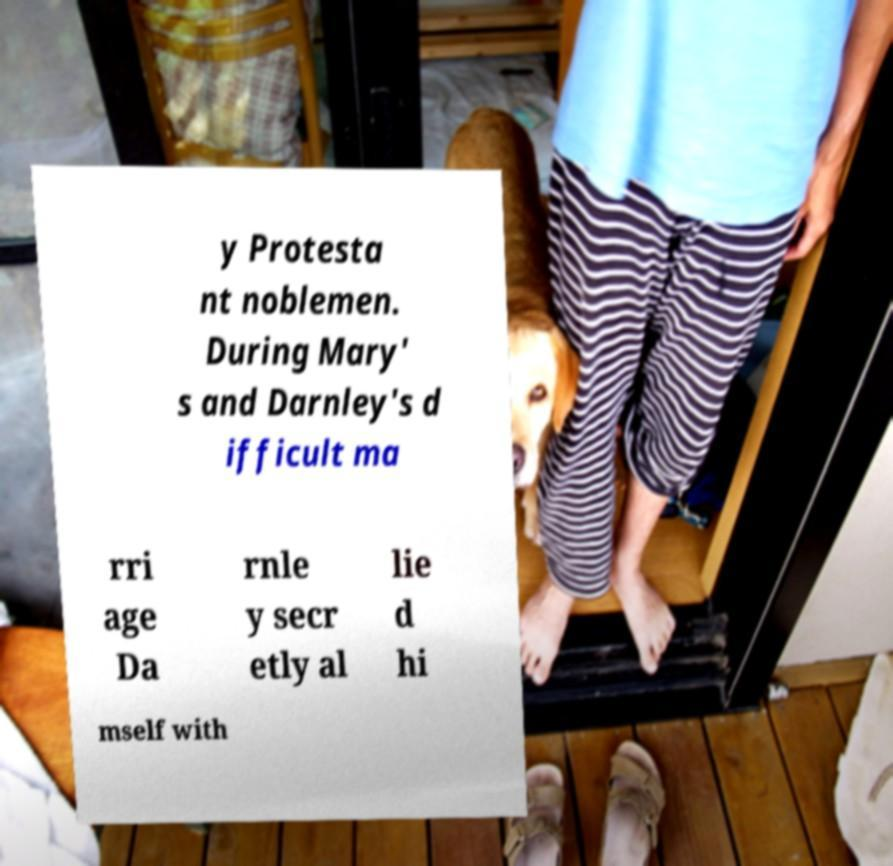There's text embedded in this image that I need extracted. Can you transcribe it verbatim? y Protesta nt noblemen. During Mary' s and Darnley's d ifficult ma rri age Da rnle y secr etly al lie d hi mself with 